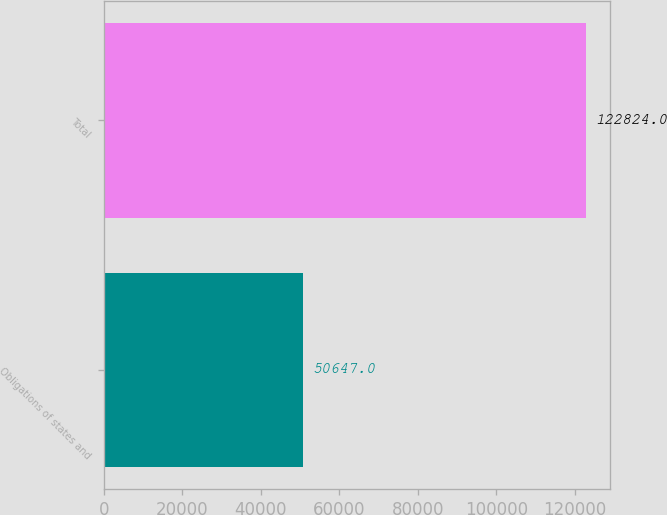Convert chart. <chart><loc_0><loc_0><loc_500><loc_500><bar_chart><fcel>Obligations of states and<fcel>Total<nl><fcel>50647<fcel>122824<nl></chart> 